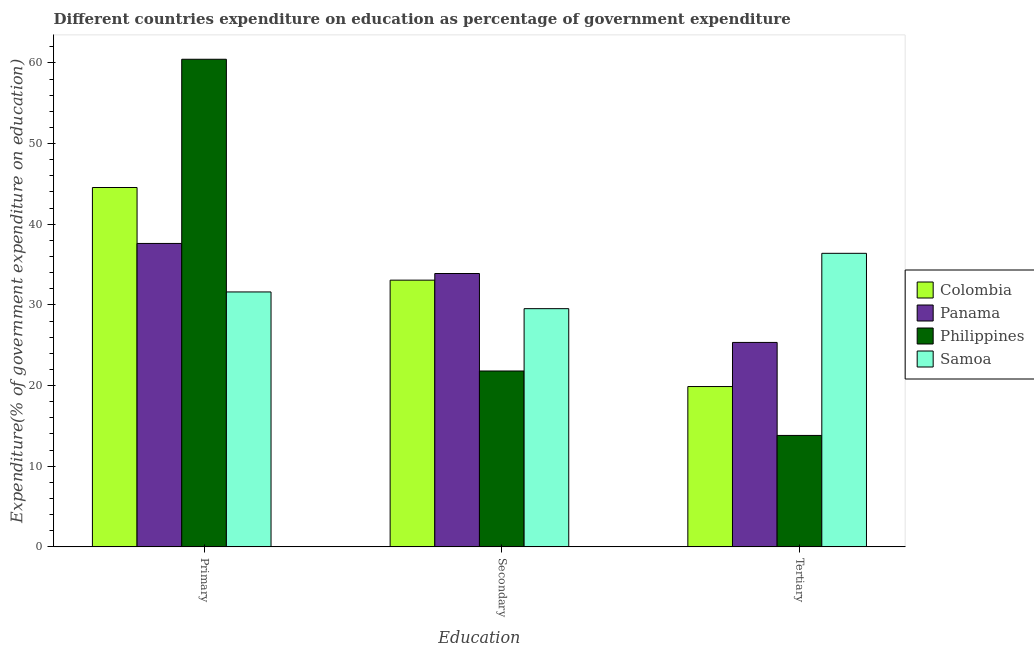How many different coloured bars are there?
Provide a succinct answer. 4. Are the number of bars on each tick of the X-axis equal?
Ensure brevity in your answer.  Yes. What is the label of the 3rd group of bars from the left?
Provide a short and direct response. Tertiary. What is the expenditure on primary education in Colombia?
Your answer should be very brief. 44.56. Across all countries, what is the maximum expenditure on primary education?
Ensure brevity in your answer.  60.46. Across all countries, what is the minimum expenditure on secondary education?
Your response must be concise. 21.81. In which country was the expenditure on primary education minimum?
Your response must be concise. Samoa. What is the total expenditure on tertiary education in the graph?
Offer a terse response. 95.44. What is the difference between the expenditure on primary education in Philippines and that in Samoa?
Provide a short and direct response. 28.85. What is the difference between the expenditure on tertiary education in Philippines and the expenditure on primary education in Colombia?
Make the answer very short. -30.74. What is the average expenditure on secondary education per country?
Your response must be concise. 29.58. What is the difference between the expenditure on primary education and expenditure on tertiary education in Colombia?
Provide a short and direct response. 24.68. In how many countries, is the expenditure on primary education greater than 16 %?
Your response must be concise. 4. What is the ratio of the expenditure on secondary education in Colombia to that in Panama?
Keep it short and to the point. 0.98. Is the expenditure on secondary education in Philippines less than that in Samoa?
Your answer should be very brief. Yes. What is the difference between the highest and the second highest expenditure on primary education?
Offer a terse response. 15.9. What is the difference between the highest and the lowest expenditure on primary education?
Your response must be concise. 28.85. In how many countries, is the expenditure on secondary education greater than the average expenditure on secondary education taken over all countries?
Make the answer very short. 2. What does the 1st bar from the left in Tertiary represents?
Offer a terse response. Colombia. What does the 4th bar from the right in Primary represents?
Give a very brief answer. Colombia. Is it the case that in every country, the sum of the expenditure on primary education and expenditure on secondary education is greater than the expenditure on tertiary education?
Your answer should be very brief. Yes. How many bars are there?
Keep it short and to the point. 12. How many countries are there in the graph?
Offer a very short reply. 4. Are the values on the major ticks of Y-axis written in scientific E-notation?
Your answer should be compact. No. Does the graph contain any zero values?
Your answer should be compact. No. Does the graph contain grids?
Your answer should be very brief. No. Where does the legend appear in the graph?
Keep it short and to the point. Center right. What is the title of the graph?
Provide a short and direct response. Different countries expenditure on education as percentage of government expenditure. What is the label or title of the X-axis?
Your response must be concise. Education. What is the label or title of the Y-axis?
Your response must be concise. Expenditure(% of government expenditure on education). What is the Expenditure(% of government expenditure on education) of Colombia in Primary?
Your answer should be very brief. 44.56. What is the Expenditure(% of government expenditure on education) of Panama in Primary?
Make the answer very short. 37.62. What is the Expenditure(% of government expenditure on education) in Philippines in Primary?
Your answer should be very brief. 60.46. What is the Expenditure(% of government expenditure on education) of Samoa in Primary?
Keep it short and to the point. 31.61. What is the Expenditure(% of government expenditure on education) in Colombia in Secondary?
Provide a short and direct response. 33.07. What is the Expenditure(% of government expenditure on education) in Panama in Secondary?
Offer a very short reply. 33.89. What is the Expenditure(% of government expenditure on education) in Philippines in Secondary?
Offer a very short reply. 21.81. What is the Expenditure(% of government expenditure on education) in Samoa in Secondary?
Give a very brief answer. 29.53. What is the Expenditure(% of government expenditure on education) of Colombia in Tertiary?
Offer a terse response. 19.88. What is the Expenditure(% of government expenditure on education) of Panama in Tertiary?
Offer a very short reply. 25.35. What is the Expenditure(% of government expenditure on education) in Philippines in Tertiary?
Your response must be concise. 13.82. What is the Expenditure(% of government expenditure on education) in Samoa in Tertiary?
Your answer should be compact. 36.4. Across all Education, what is the maximum Expenditure(% of government expenditure on education) of Colombia?
Provide a short and direct response. 44.56. Across all Education, what is the maximum Expenditure(% of government expenditure on education) of Panama?
Offer a very short reply. 37.62. Across all Education, what is the maximum Expenditure(% of government expenditure on education) of Philippines?
Provide a short and direct response. 60.46. Across all Education, what is the maximum Expenditure(% of government expenditure on education) of Samoa?
Offer a very short reply. 36.4. Across all Education, what is the minimum Expenditure(% of government expenditure on education) in Colombia?
Provide a succinct answer. 19.88. Across all Education, what is the minimum Expenditure(% of government expenditure on education) in Panama?
Your answer should be compact. 25.35. Across all Education, what is the minimum Expenditure(% of government expenditure on education) in Philippines?
Your answer should be very brief. 13.82. Across all Education, what is the minimum Expenditure(% of government expenditure on education) of Samoa?
Ensure brevity in your answer.  29.53. What is the total Expenditure(% of government expenditure on education) in Colombia in the graph?
Your response must be concise. 97.51. What is the total Expenditure(% of government expenditure on education) of Panama in the graph?
Give a very brief answer. 96.86. What is the total Expenditure(% of government expenditure on education) of Philippines in the graph?
Your answer should be very brief. 96.08. What is the total Expenditure(% of government expenditure on education) in Samoa in the graph?
Your answer should be compact. 97.54. What is the difference between the Expenditure(% of government expenditure on education) of Colombia in Primary and that in Secondary?
Offer a very short reply. 11.49. What is the difference between the Expenditure(% of government expenditure on education) of Panama in Primary and that in Secondary?
Keep it short and to the point. 3.73. What is the difference between the Expenditure(% of government expenditure on education) in Philippines in Primary and that in Secondary?
Offer a terse response. 38.65. What is the difference between the Expenditure(% of government expenditure on education) in Samoa in Primary and that in Secondary?
Provide a short and direct response. 2.07. What is the difference between the Expenditure(% of government expenditure on education) in Colombia in Primary and that in Tertiary?
Give a very brief answer. 24.68. What is the difference between the Expenditure(% of government expenditure on education) in Panama in Primary and that in Tertiary?
Offer a very short reply. 12.27. What is the difference between the Expenditure(% of government expenditure on education) in Philippines in Primary and that in Tertiary?
Provide a short and direct response. 46.64. What is the difference between the Expenditure(% of government expenditure on education) of Samoa in Primary and that in Tertiary?
Keep it short and to the point. -4.79. What is the difference between the Expenditure(% of government expenditure on education) in Colombia in Secondary and that in Tertiary?
Keep it short and to the point. 13.19. What is the difference between the Expenditure(% of government expenditure on education) of Panama in Secondary and that in Tertiary?
Your answer should be very brief. 8.55. What is the difference between the Expenditure(% of government expenditure on education) of Philippines in Secondary and that in Tertiary?
Your answer should be very brief. 7.99. What is the difference between the Expenditure(% of government expenditure on education) in Samoa in Secondary and that in Tertiary?
Provide a short and direct response. -6.86. What is the difference between the Expenditure(% of government expenditure on education) of Colombia in Primary and the Expenditure(% of government expenditure on education) of Panama in Secondary?
Your answer should be very brief. 10.66. What is the difference between the Expenditure(% of government expenditure on education) in Colombia in Primary and the Expenditure(% of government expenditure on education) in Philippines in Secondary?
Make the answer very short. 22.75. What is the difference between the Expenditure(% of government expenditure on education) of Colombia in Primary and the Expenditure(% of government expenditure on education) of Samoa in Secondary?
Keep it short and to the point. 15.02. What is the difference between the Expenditure(% of government expenditure on education) of Panama in Primary and the Expenditure(% of government expenditure on education) of Philippines in Secondary?
Ensure brevity in your answer.  15.81. What is the difference between the Expenditure(% of government expenditure on education) of Panama in Primary and the Expenditure(% of government expenditure on education) of Samoa in Secondary?
Make the answer very short. 8.09. What is the difference between the Expenditure(% of government expenditure on education) in Philippines in Primary and the Expenditure(% of government expenditure on education) in Samoa in Secondary?
Provide a short and direct response. 30.93. What is the difference between the Expenditure(% of government expenditure on education) of Colombia in Primary and the Expenditure(% of government expenditure on education) of Panama in Tertiary?
Your answer should be very brief. 19.21. What is the difference between the Expenditure(% of government expenditure on education) of Colombia in Primary and the Expenditure(% of government expenditure on education) of Philippines in Tertiary?
Your answer should be very brief. 30.74. What is the difference between the Expenditure(% of government expenditure on education) of Colombia in Primary and the Expenditure(% of government expenditure on education) of Samoa in Tertiary?
Provide a succinct answer. 8.16. What is the difference between the Expenditure(% of government expenditure on education) of Panama in Primary and the Expenditure(% of government expenditure on education) of Philippines in Tertiary?
Provide a short and direct response. 23.8. What is the difference between the Expenditure(% of government expenditure on education) in Panama in Primary and the Expenditure(% of government expenditure on education) in Samoa in Tertiary?
Offer a very short reply. 1.22. What is the difference between the Expenditure(% of government expenditure on education) of Philippines in Primary and the Expenditure(% of government expenditure on education) of Samoa in Tertiary?
Offer a very short reply. 24.06. What is the difference between the Expenditure(% of government expenditure on education) of Colombia in Secondary and the Expenditure(% of government expenditure on education) of Panama in Tertiary?
Make the answer very short. 7.72. What is the difference between the Expenditure(% of government expenditure on education) of Colombia in Secondary and the Expenditure(% of government expenditure on education) of Philippines in Tertiary?
Provide a succinct answer. 19.25. What is the difference between the Expenditure(% of government expenditure on education) of Colombia in Secondary and the Expenditure(% of government expenditure on education) of Samoa in Tertiary?
Ensure brevity in your answer.  -3.33. What is the difference between the Expenditure(% of government expenditure on education) in Panama in Secondary and the Expenditure(% of government expenditure on education) in Philippines in Tertiary?
Offer a terse response. 20.08. What is the difference between the Expenditure(% of government expenditure on education) in Panama in Secondary and the Expenditure(% of government expenditure on education) in Samoa in Tertiary?
Ensure brevity in your answer.  -2.5. What is the difference between the Expenditure(% of government expenditure on education) of Philippines in Secondary and the Expenditure(% of government expenditure on education) of Samoa in Tertiary?
Provide a succinct answer. -14.59. What is the average Expenditure(% of government expenditure on education) in Colombia per Education?
Your answer should be compact. 32.5. What is the average Expenditure(% of government expenditure on education) in Panama per Education?
Give a very brief answer. 32.29. What is the average Expenditure(% of government expenditure on education) of Philippines per Education?
Keep it short and to the point. 32.03. What is the average Expenditure(% of government expenditure on education) in Samoa per Education?
Give a very brief answer. 32.51. What is the difference between the Expenditure(% of government expenditure on education) in Colombia and Expenditure(% of government expenditure on education) in Panama in Primary?
Provide a succinct answer. 6.94. What is the difference between the Expenditure(% of government expenditure on education) of Colombia and Expenditure(% of government expenditure on education) of Philippines in Primary?
Give a very brief answer. -15.9. What is the difference between the Expenditure(% of government expenditure on education) in Colombia and Expenditure(% of government expenditure on education) in Samoa in Primary?
Give a very brief answer. 12.95. What is the difference between the Expenditure(% of government expenditure on education) of Panama and Expenditure(% of government expenditure on education) of Philippines in Primary?
Provide a short and direct response. -22.84. What is the difference between the Expenditure(% of government expenditure on education) of Panama and Expenditure(% of government expenditure on education) of Samoa in Primary?
Your response must be concise. 6.01. What is the difference between the Expenditure(% of government expenditure on education) in Philippines and Expenditure(% of government expenditure on education) in Samoa in Primary?
Give a very brief answer. 28.85. What is the difference between the Expenditure(% of government expenditure on education) of Colombia and Expenditure(% of government expenditure on education) of Panama in Secondary?
Keep it short and to the point. -0.82. What is the difference between the Expenditure(% of government expenditure on education) in Colombia and Expenditure(% of government expenditure on education) in Philippines in Secondary?
Ensure brevity in your answer.  11.26. What is the difference between the Expenditure(% of government expenditure on education) in Colombia and Expenditure(% of government expenditure on education) in Samoa in Secondary?
Offer a terse response. 3.54. What is the difference between the Expenditure(% of government expenditure on education) of Panama and Expenditure(% of government expenditure on education) of Philippines in Secondary?
Your answer should be compact. 12.09. What is the difference between the Expenditure(% of government expenditure on education) in Panama and Expenditure(% of government expenditure on education) in Samoa in Secondary?
Offer a very short reply. 4.36. What is the difference between the Expenditure(% of government expenditure on education) in Philippines and Expenditure(% of government expenditure on education) in Samoa in Secondary?
Ensure brevity in your answer.  -7.73. What is the difference between the Expenditure(% of government expenditure on education) of Colombia and Expenditure(% of government expenditure on education) of Panama in Tertiary?
Ensure brevity in your answer.  -5.47. What is the difference between the Expenditure(% of government expenditure on education) of Colombia and Expenditure(% of government expenditure on education) of Philippines in Tertiary?
Offer a very short reply. 6.06. What is the difference between the Expenditure(% of government expenditure on education) of Colombia and Expenditure(% of government expenditure on education) of Samoa in Tertiary?
Give a very brief answer. -16.52. What is the difference between the Expenditure(% of government expenditure on education) of Panama and Expenditure(% of government expenditure on education) of Philippines in Tertiary?
Make the answer very short. 11.53. What is the difference between the Expenditure(% of government expenditure on education) of Panama and Expenditure(% of government expenditure on education) of Samoa in Tertiary?
Provide a succinct answer. -11.05. What is the difference between the Expenditure(% of government expenditure on education) in Philippines and Expenditure(% of government expenditure on education) in Samoa in Tertiary?
Provide a short and direct response. -22.58. What is the ratio of the Expenditure(% of government expenditure on education) in Colombia in Primary to that in Secondary?
Offer a terse response. 1.35. What is the ratio of the Expenditure(% of government expenditure on education) in Panama in Primary to that in Secondary?
Offer a terse response. 1.11. What is the ratio of the Expenditure(% of government expenditure on education) in Philippines in Primary to that in Secondary?
Your answer should be compact. 2.77. What is the ratio of the Expenditure(% of government expenditure on education) of Samoa in Primary to that in Secondary?
Offer a terse response. 1.07. What is the ratio of the Expenditure(% of government expenditure on education) in Colombia in Primary to that in Tertiary?
Keep it short and to the point. 2.24. What is the ratio of the Expenditure(% of government expenditure on education) of Panama in Primary to that in Tertiary?
Give a very brief answer. 1.48. What is the ratio of the Expenditure(% of government expenditure on education) of Philippines in Primary to that in Tertiary?
Keep it short and to the point. 4.38. What is the ratio of the Expenditure(% of government expenditure on education) of Samoa in Primary to that in Tertiary?
Offer a very short reply. 0.87. What is the ratio of the Expenditure(% of government expenditure on education) of Colombia in Secondary to that in Tertiary?
Make the answer very short. 1.66. What is the ratio of the Expenditure(% of government expenditure on education) of Panama in Secondary to that in Tertiary?
Give a very brief answer. 1.34. What is the ratio of the Expenditure(% of government expenditure on education) of Philippines in Secondary to that in Tertiary?
Keep it short and to the point. 1.58. What is the ratio of the Expenditure(% of government expenditure on education) of Samoa in Secondary to that in Tertiary?
Give a very brief answer. 0.81. What is the difference between the highest and the second highest Expenditure(% of government expenditure on education) in Colombia?
Offer a very short reply. 11.49. What is the difference between the highest and the second highest Expenditure(% of government expenditure on education) in Panama?
Make the answer very short. 3.73. What is the difference between the highest and the second highest Expenditure(% of government expenditure on education) of Philippines?
Your response must be concise. 38.65. What is the difference between the highest and the second highest Expenditure(% of government expenditure on education) in Samoa?
Offer a terse response. 4.79. What is the difference between the highest and the lowest Expenditure(% of government expenditure on education) of Colombia?
Your answer should be very brief. 24.68. What is the difference between the highest and the lowest Expenditure(% of government expenditure on education) of Panama?
Offer a very short reply. 12.27. What is the difference between the highest and the lowest Expenditure(% of government expenditure on education) in Philippines?
Your answer should be very brief. 46.64. What is the difference between the highest and the lowest Expenditure(% of government expenditure on education) of Samoa?
Offer a very short reply. 6.86. 